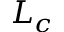<formula> <loc_0><loc_0><loc_500><loc_500>L _ { c }</formula> 